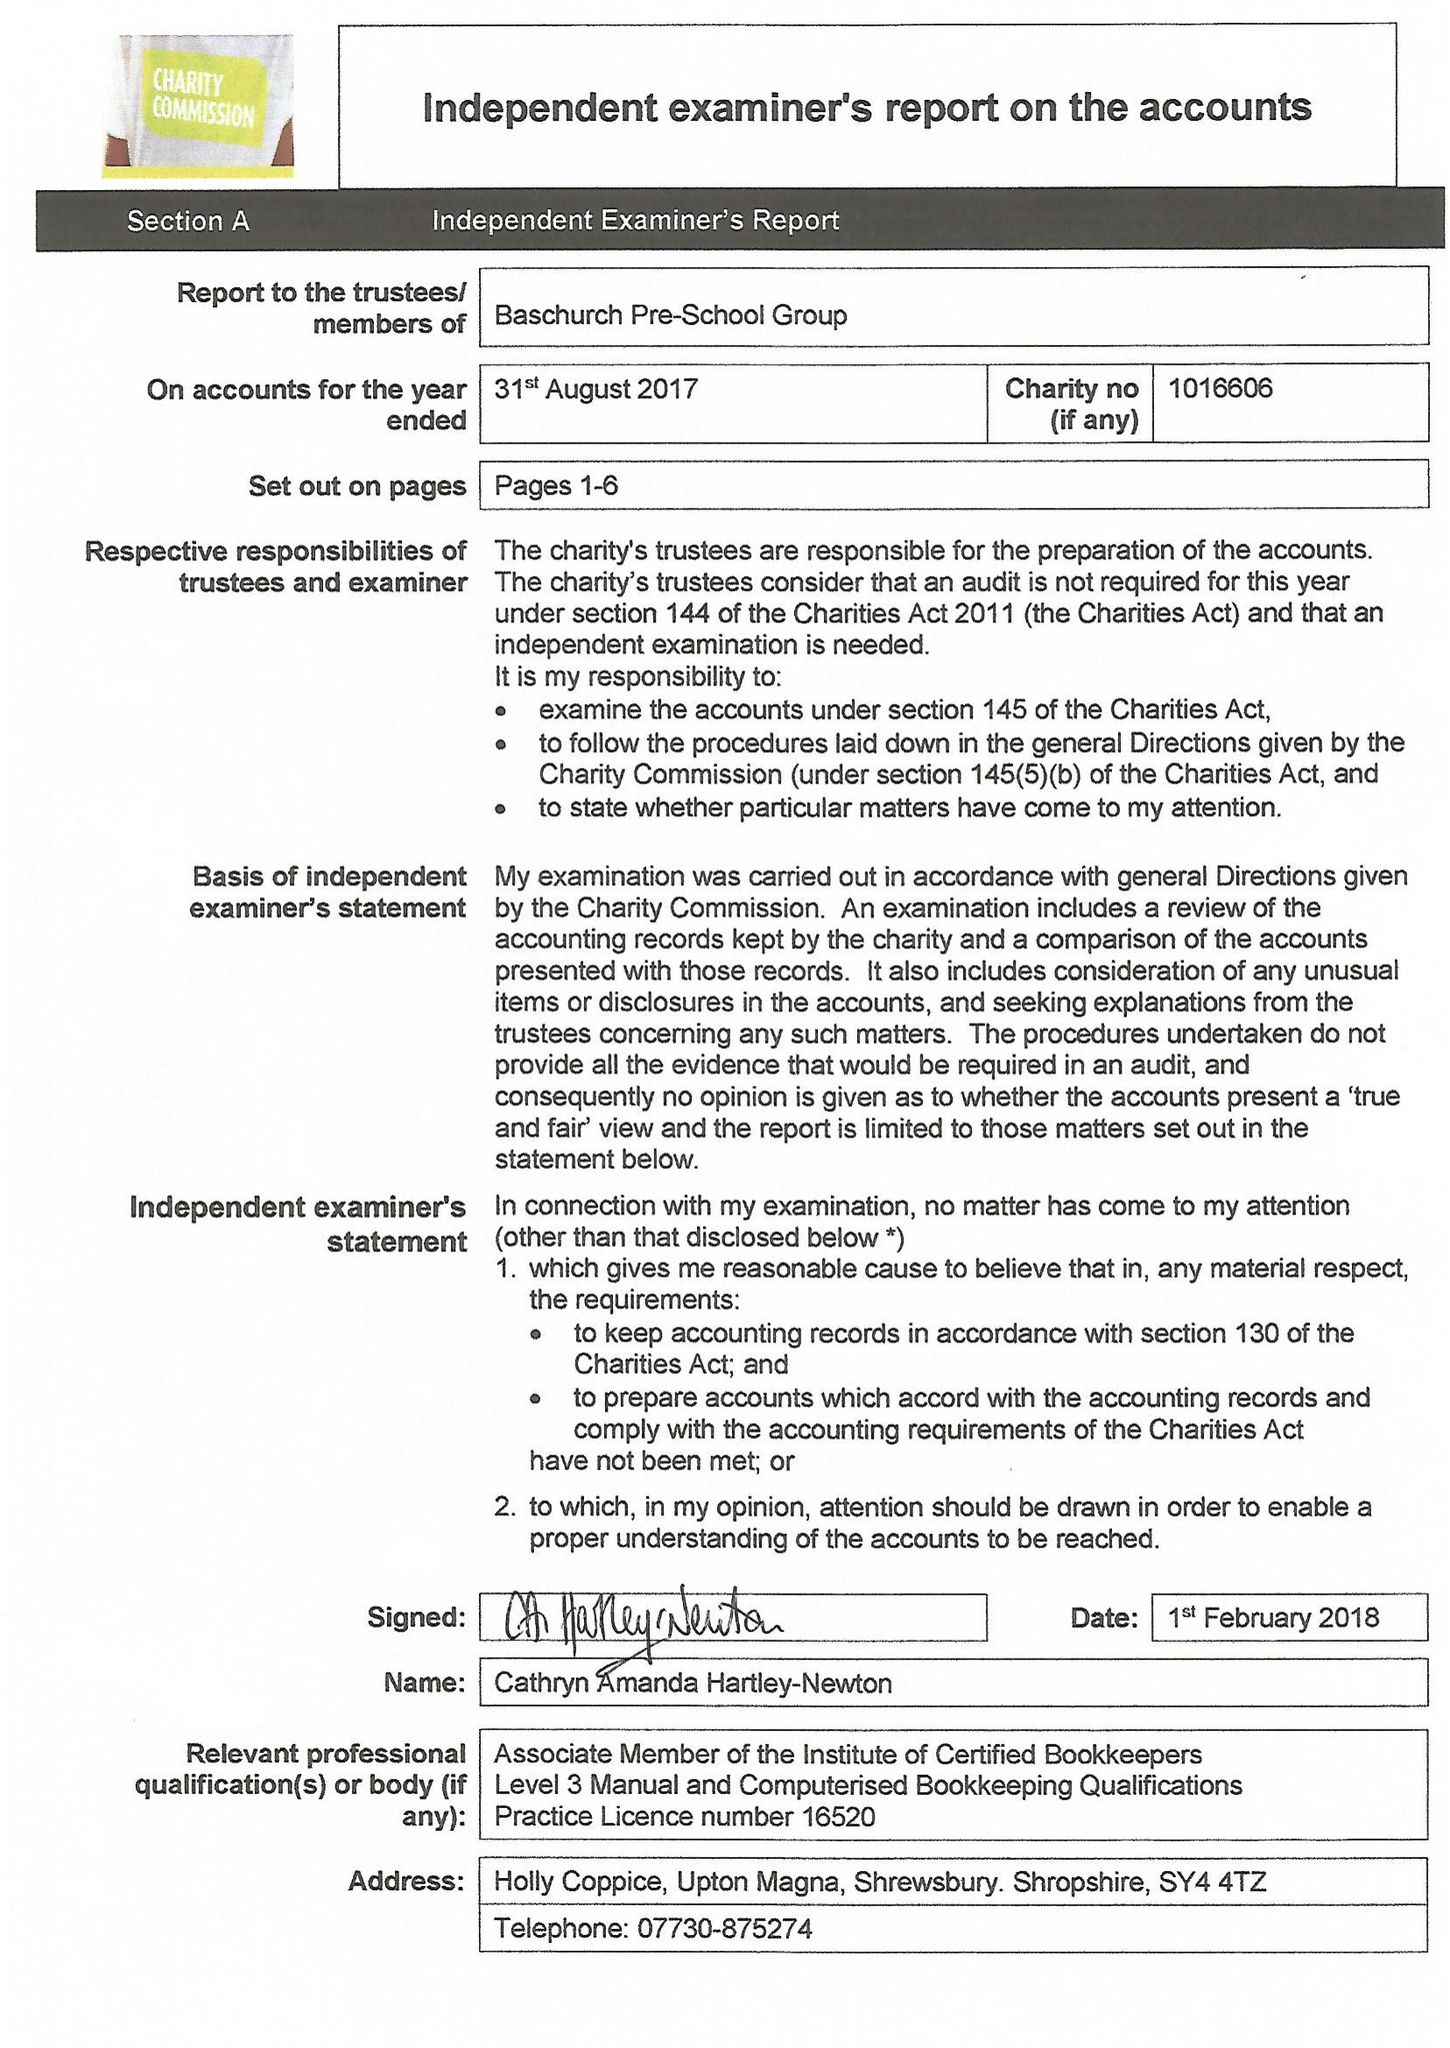What is the value for the income_annually_in_british_pounds?
Answer the question using a single word or phrase. 93730.00 